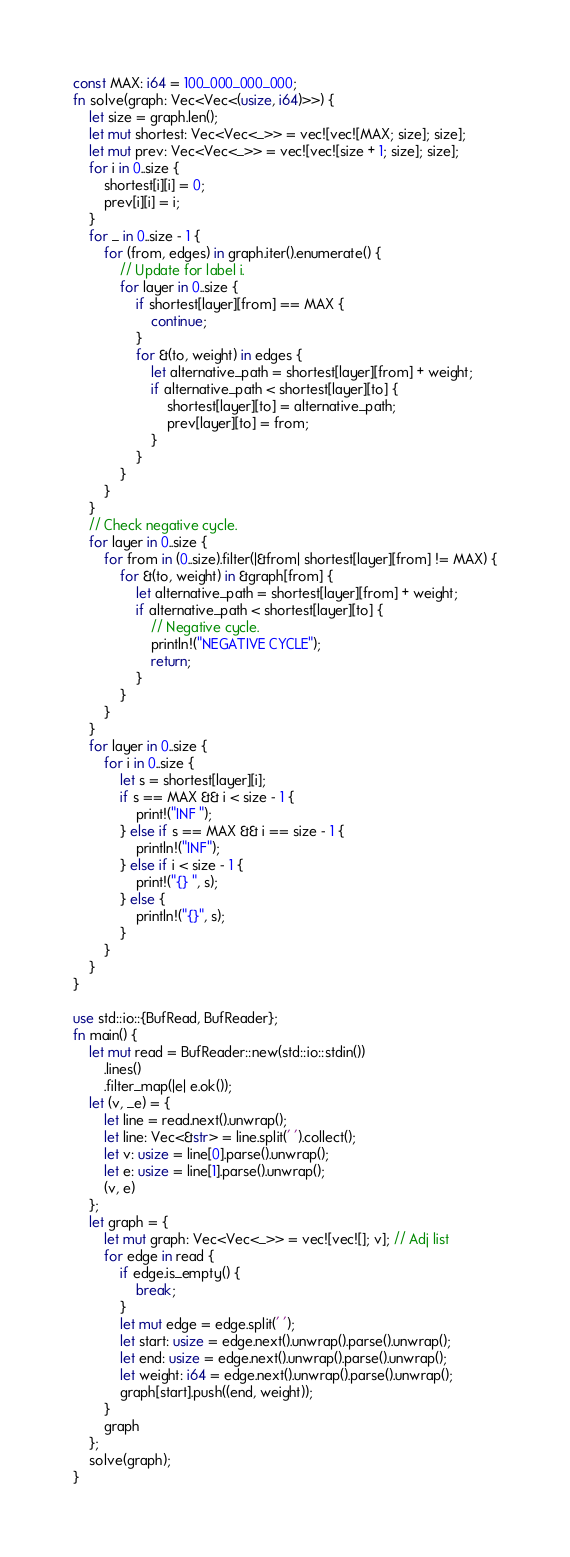Convert code to text. <code><loc_0><loc_0><loc_500><loc_500><_Rust_>const MAX: i64 = 100_000_000_000;
fn solve(graph: Vec<Vec<(usize, i64)>>) {
    let size = graph.len();
    let mut shortest: Vec<Vec<_>> = vec![vec![MAX; size]; size];
    let mut prev: Vec<Vec<_>> = vec![vec![size + 1; size]; size];
    for i in 0..size {
        shortest[i][i] = 0;
        prev[i][i] = i;
    }
    for _ in 0..size - 1 {
        for (from, edges) in graph.iter().enumerate() {
            // Update for label i.
            for layer in 0..size {
                if shortest[layer][from] == MAX {
                    continue;
                }
                for &(to, weight) in edges {
                    let alternative_path = shortest[layer][from] + weight;
                    if alternative_path < shortest[layer][to] {
                        shortest[layer][to] = alternative_path;
                        prev[layer][to] = from;
                    }
                }
            }
        }
    }
    // Check negative cycle.
    for layer in 0..size {
        for from in (0..size).filter(|&from| shortest[layer][from] != MAX) {
            for &(to, weight) in &graph[from] {
                let alternative_path = shortest[layer][from] + weight;
                if alternative_path < shortest[layer][to] {
                    // Negative cycle.
                    println!("NEGATIVE CYCLE");
                    return;
                }
            }
        }
    }
    for layer in 0..size {
        for i in 0..size {
            let s = shortest[layer][i];
            if s == MAX && i < size - 1 {
                print!("INF ");
            } else if s == MAX && i == size - 1 {
                println!("INF");
            } else if i < size - 1 {
                print!("{} ", s);
            } else {
                println!("{}", s);
            }
        }
    }
}

use std::io::{BufRead, BufReader};
fn main() {
    let mut read = BufReader::new(std::io::stdin())
        .lines()
        .filter_map(|e| e.ok());
    let (v, _e) = {
        let line = read.next().unwrap();
        let line: Vec<&str> = line.split(' ').collect();
        let v: usize = line[0].parse().unwrap();
        let e: usize = line[1].parse().unwrap();
        (v, e)
    };
    let graph = {
        let mut graph: Vec<Vec<_>> = vec![vec![]; v]; // Adj list
        for edge in read {
            if edge.is_empty() {
                break;
            }
            let mut edge = edge.split(' ');
            let start: usize = edge.next().unwrap().parse().unwrap();
            let end: usize = edge.next().unwrap().parse().unwrap();
            let weight: i64 = edge.next().unwrap().parse().unwrap();
            graph[start].push((end, weight));
        }
        graph
    };
    solve(graph);
}

</code> 